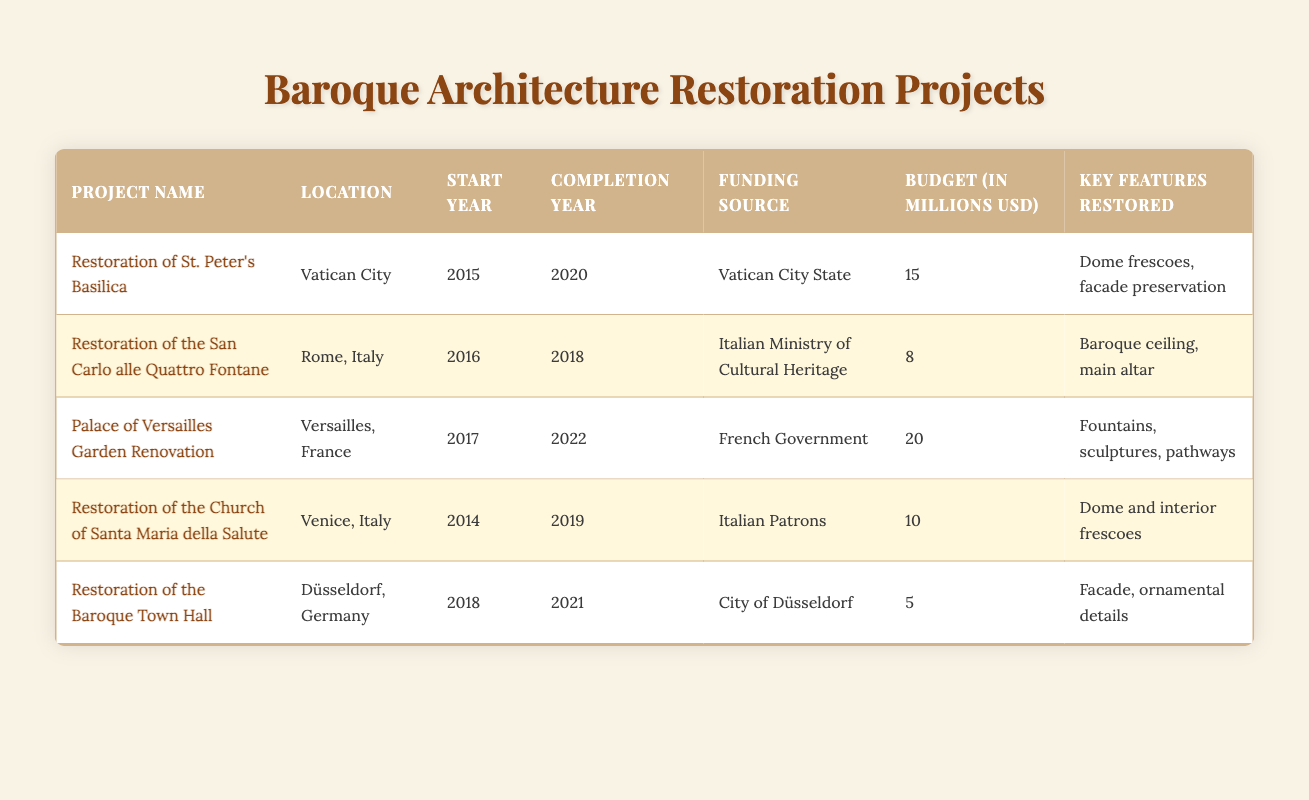What is the funding source for the restoration of St. Peter's Basilica? The table indicates that the funding source for the restoration of St. Peter's Basilica is "Vatican City State".
Answer: Vatican City State Which project had the highest budget? By reviewing the budget column, the highest budget listed is for the "Palace of Versailles Garden Renovation," which has a budget of 20 million USD.
Answer: 20 million USD How many years did the restoration of the Church of Santa Maria della Salute take to complete? The restoration started in 2014 and was completed in 2019. To find the duration, subtract the start year from the completion year: 2019 - 2014 = 5 years.
Answer: 5 years Is the restoration of the Baroque Town Hall funded by a government? The table shows that the funding source for the restoration of the Baroque Town Hall is "City of Düsseldorf," which implies it is funded by a local government.
Answer: Yes What is the average budget for the restoration projects listed in the table? First, we total the budgets: 15 + 8 + 20 + 10 + 5 = 58 million USD. There are 5 projects, so we divide the total by the number of projects: 58 / 5 = 11.6 million USD.
Answer: 11.6 million USD Which project was completed in 2021 and what were its key features restored? The table shows that the "Restoration of the Baroque Town Hall" was completed in 2021, and its key features restored include the facade and ornamental details.
Answer: Restoration of the Baroque Town Hall; facade and ornamental details How many projects had a funding source from the government? Upon analyzing the funding sources, it appears that three projects: "Palace of Versailles Garden Renovation," "Restoration of the San Carlo alle Quattro Fontane," and "Restoration of the Baroque Town Hall" had government funding, either national or local.
Answer: 3 projects Which project restored dome frescoes and when did it start? The "Restoration of St. Peter's Basilica" is identified in the table as restoring dome frescoes, and it started in the year 2015.
Answer: 2015 